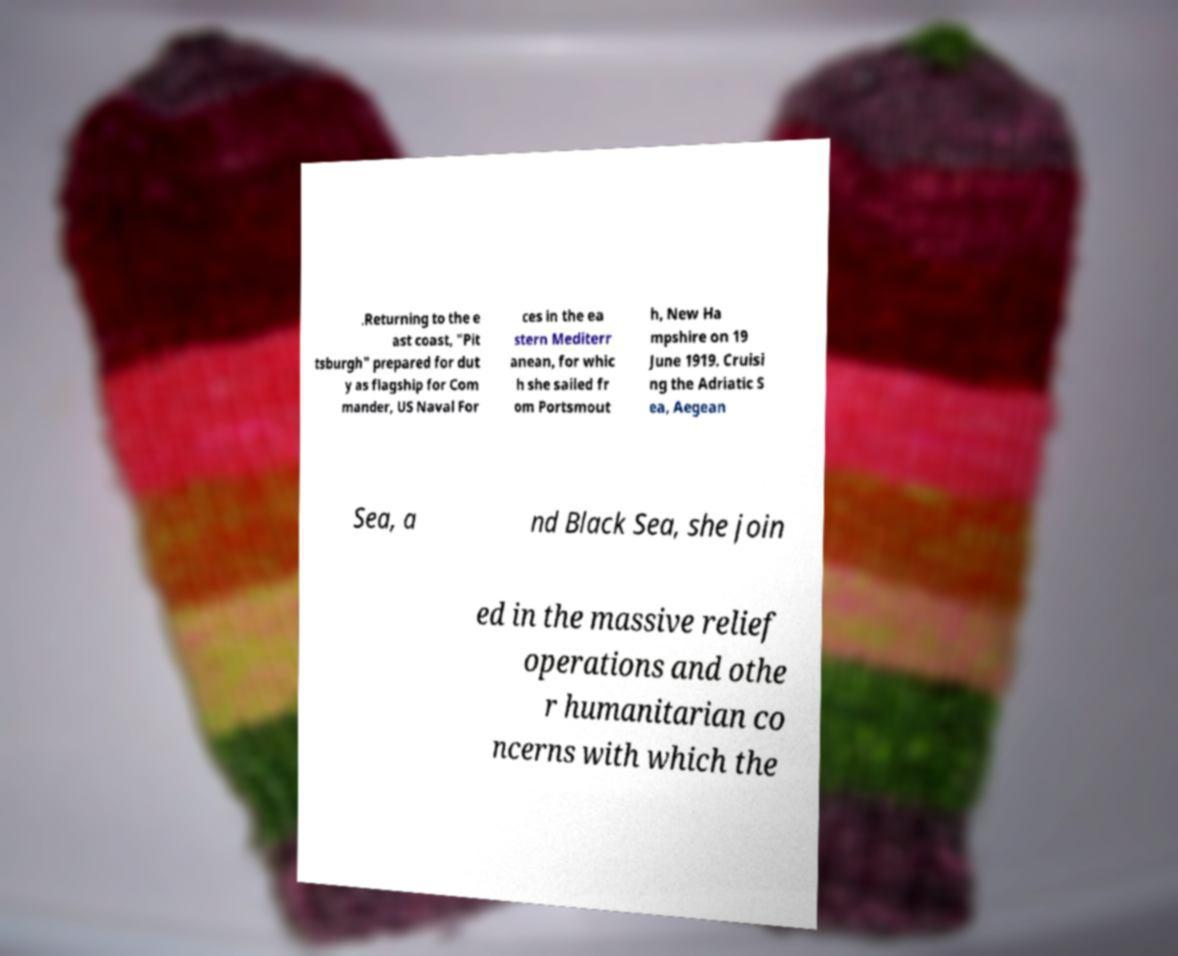What messages or text are displayed in this image? I need them in a readable, typed format. .Returning to the e ast coast, "Pit tsburgh" prepared for dut y as flagship for Com mander, US Naval For ces in the ea stern Mediterr anean, for whic h she sailed fr om Portsmout h, New Ha mpshire on 19 June 1919. Cruisi ng the Adriatic S ea, Aegean Sea, a nd Black Sea, she join ed in the massive relief operations and othe r humanitarian co ncerns with which the 